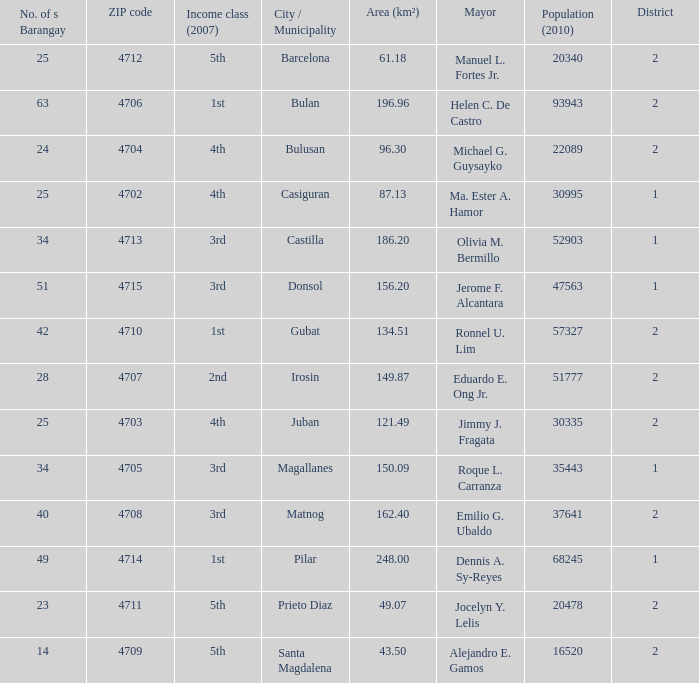What are all the profits elegance (2007) in which mayor is ma. Ester a. Hamor 4th. 